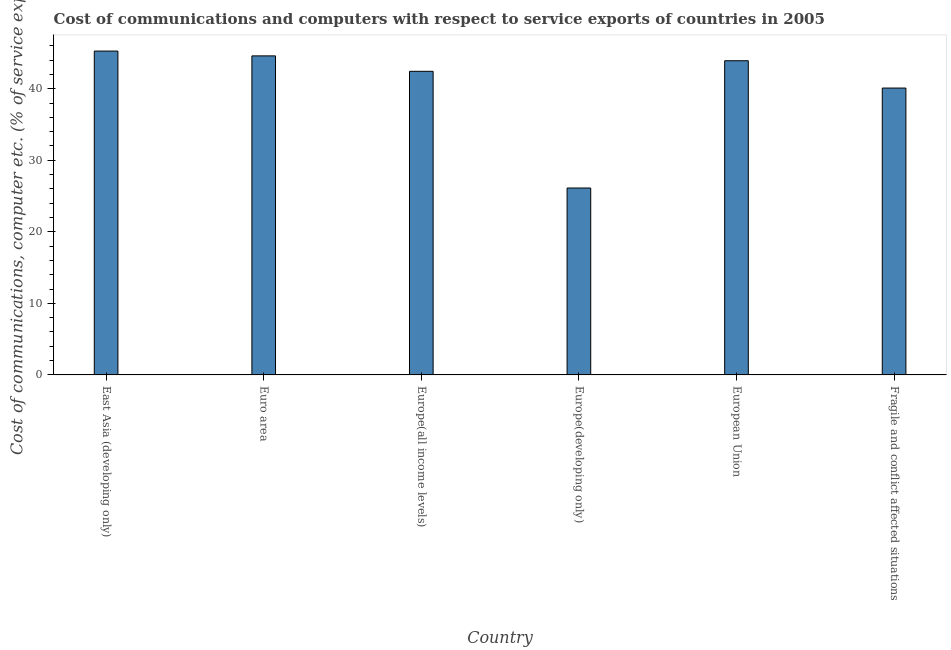Does the graph contain any zero values?
Keep it short and to the point. No. What is the title of the graph?
Ensure brevity in your answer.  Cost of communications and computers with respect to service exports of countries in 2005. What is the label or title of the Y-axis?
Your response must be concise. Cost of communications, computer etc. (% of service exports). What is the cost of communications and computer in European Union?
Keep it short and to the point. 43.91. Across all countries, what is the maximum cost of communications and computer?
Keep it short and to the point. 45.26. Across all countries, what is the minimum cost of communications and computer?
Your answer should be very brief. 26.12. In which country was the cost of communications and computer maximum?
Make the answer very short. East Asia (developing only). In which country was the cost of communications and computer minimum?
Give a very brief answer. Europe(developing only). What is the sum of the cost of communications and computer?
Provide a short and direct response. 242.41. What is the difference between the cost of communications and computer in East Asia (developing only) and Europe(all income levels)?
Keep it short and to the point. 2.83. What is the average cost of communications and computer per country?
Give a very brief answer. 40.4. What is the median cost of communications and computer?
Offer a very short reply. 43.17. What is the ratio of the cost of communications and computer in Europe(all income levels) to that in Fragile and conflict affected situations?
Your response must be concise. 1.06. What is the difference between the highest and the second highest cost of communications and computer?
Your response must be concise. 0.67. Is the sum of the cost of communications and computer in Europe(developing only) and European Union greater than the maximum cost of communications and computer across all countries?
Offer a terse response. Yes. What is the difference between the highest and the lowest cost of communications and computer?
Provide a succinct answer. 19.14. How many countries are there in the graph?
Your answer should be compact. 6. What is the difference between two consecutive major ticks on the Y-axis?
Offer a very short reply. 10. What is the Cost of communications, computer etc. (% of service exports) of East Asia (developing only)?
Provide a short and direct response. 45.26. What is the Cost of communications, computer etc. (% of service exports) of Euro area?
Your response must be concise. 44.59. What is the Cost of communications, computer etc. (% of service exports) of Europe(all income levels)?
Provide a short and direct response. 42.43. What is the Cost of communications, computer etc. (% of service exports) of Europe(developing only)?
Ensure brevity in your answer.  26.12. What is the Cost of communications, computer etc. (% of service exports) in European Union?
Ensure brevity in your answer.  43.91. What is the Cost of communications, computer etc. (% of service exports) of Fragile and conflict affected situations?
Make the answer very short. 40.09. What is the difference between the Cost of communications, computer etc. (% of service exports) in East Asia (developing only) and Euro area?
Make the answer very short. 0.67. What is the difference between the Cost of communications, computer etc. (% of service exports) in East Asia (developing only) and Europe(all income levels)?
Provide a succinct answer. 2.83. What is the difference between the Cost of communications, computer etc. (% of service exports) in East Asia (developing only) and Europe(developing only)?
Offer a very short reply. 19.14. What is the difference between the Cost of communications, computer etc. (% of service exports) in East Asia (developing only) and European Union?
Your answer should be compact. 1.35. What is the difference between the Cost of communications, computer etc. (% of service exports) in East Asia (developing only) and Fragile and conflict affected situations?
Offer a terse response. 5.17. What is the difference between the Cost of communications, computer etc. (% of service exports) in Euro area and Europe(all income levels)?
Provide a short and direct response. 2.16. What is the difference between the Cost of communications, computer etc. (% of service exports) in Euro area and Europe(developing only)?
Make the answer very short. 18.47. What is the difference between the Cost of communications, computer etc. (% of service exports) in Euro area and European Union?
Your answer should be compact. 0.68. What is the difference between the Cost of communications, computer etc. (% of service exports) in Euro area and Fragile and conflict affected situations?
Keep it short and to the point. 4.5. What is the difference between the Cost of communications, computer etc. (% of service exports) in Europe(all income levels) and Europe(developing only)?
Make the answer very short. 16.31. What is the difference between the Cost of communications, computer etc. (% of service exports) in Europe(all income levels) and European Union?
Your response must be concise. -1.48. What is the difference between the Cost of communications, computer etc. (% of service exports) in Europe(all income levels) and Fragile and conflict affected situations?
Offer a terse response. 2.34. What is the difference between the Cost of communications, computer etc. (% of service exports) in Europe(developing only) and European Union?
Make the answer very short. -17.79. What is the difference between the Cost of communications, computer etc. (% of service exports) in Europe(developing only) and Fragile and conflict affected situations?
Make the answer very short. -13.97. What is the difference between the Cost of communications, computer etc. (% of service exports) in European Union and Fragile and conflict affected situations?
Provide a succinct answer. 3.82. What is the ratio of the Cost of communications, computer etc. (% of service exports) in East Asia (developing only) to that in Europe(all income levels)?
Ensure brevity in your answer.  1.07. What is the ratio of the Cost of communications, computer etc. (% of service exports) in East Asia (developing only) to that in Europe(developing only)?
Your response must be concise. 1.73. What is the ratio of the Cost of communications, computer etc. (% of service exports) in East Asia (developing only) to that in European Union?
Your response must be concise. 1.03. What is the ratio of the Cost of communications, computer etc. (% of service exports) in East Asia (developing only) to that in Fragile and conflict affected situations?
Provide a succinct answer. 1.13. What is the ratio of the Cost of communications, computer etc. (% of service exports) in Euro area to that in Europe(all income levels)?
Offer a terse response. 1.05. What is the ratio of the Cost of communications, computer etc. (% of service exports) in Euro area to that in Europe(developing only)?
Give a very brief answer. 1.71. What is the ratio of the Cost of communications, computer etc. (% of service exports) in Euro area to that in Fragile and conflict affected situations?
Make the answer very short. 1.11. What is the ratio of the Cost of communications, computer etc. (% of service exports) in Europe(all income levels) to that in Europe(developing only)?
Your answer should be very brief. 1.62. What is the ratio of the Cost of communications, computer etc. (% of service exports) in Europe(all income levels) to that in European Union?
Offer a terse response. 0.97. What is the ratio of the Cost of communications, computer etc. (% of service exports) in Europe(all income levels) to that in Fragile and conflict affected situations?
Provide a short and direct response. 1.06. What is the ratio of the Cost of communications, computer etc. (% of service exports) in Europe(developing only) to that in European Union?
Offer a terse response. 0.59. What is the ratio of the Cost of communications, computer etc. (% of service exports) in Europe(developing only) to that in Fragile and conflict affected situations?
Provide a short and direct response. 0.65. What is the ratio of the Cost of communications, computer etc. (% of service exports) in European Union to that in Fragile and conflict affected situations?
Your answer should be compact. 1.09. 